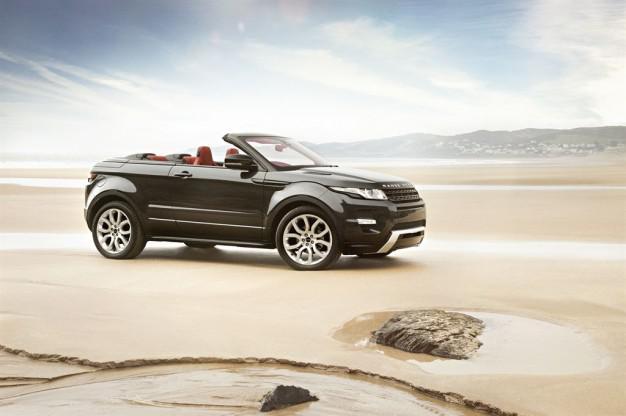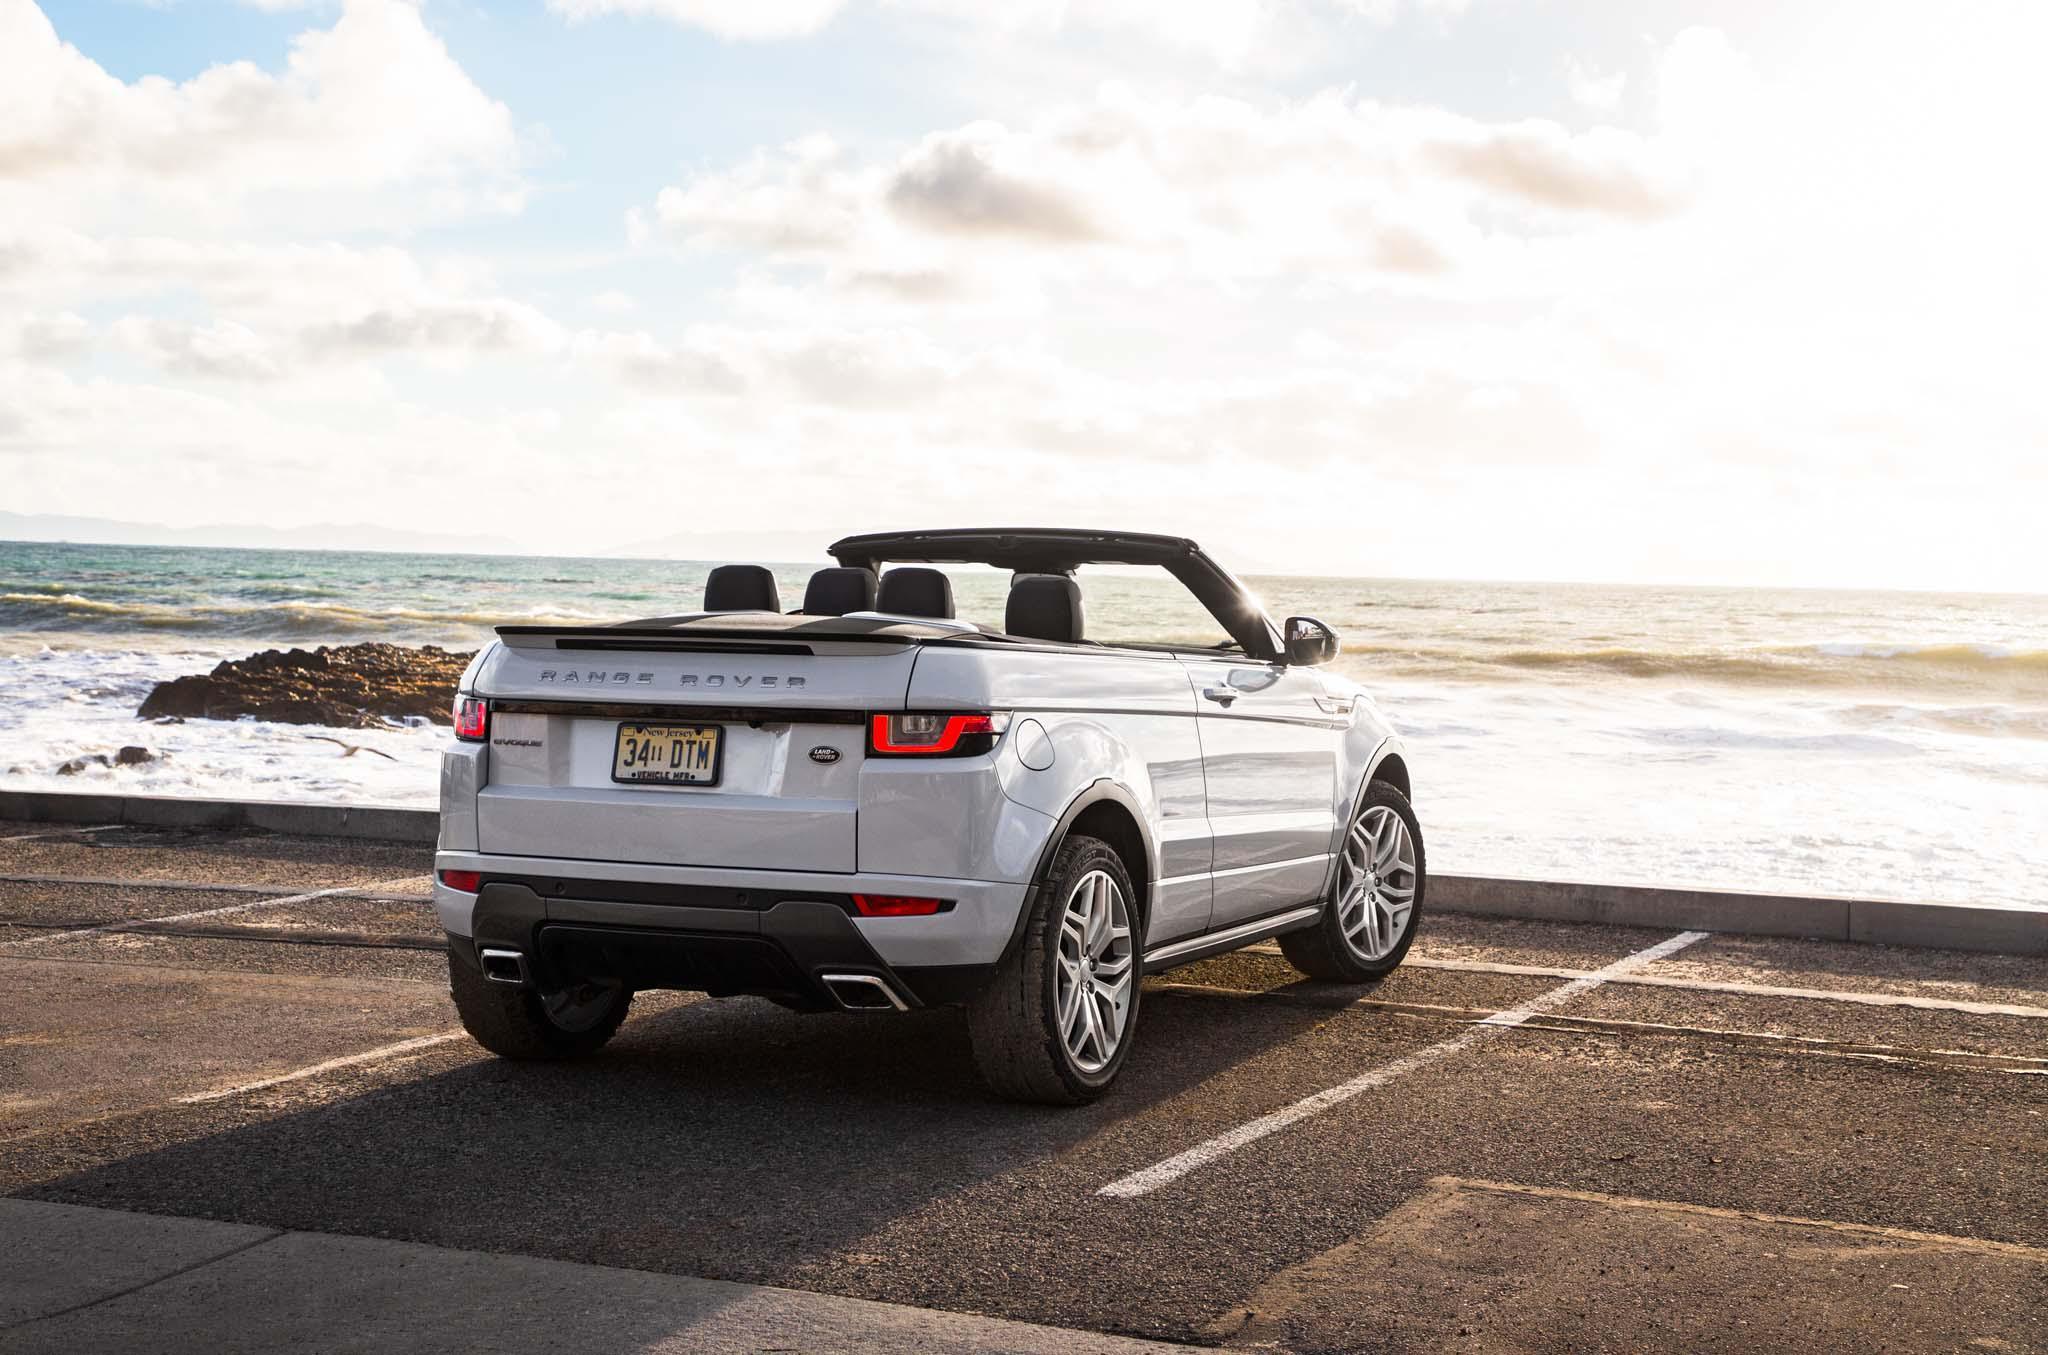The first image is the image on the left, the second image is the image on the right. For the images displayed, is the sentence "The right image features one white topless convertible parked in a marked space facing the ocean, with its rear to the camera." factually correct? Answer yes or no. Yes. The first image is the image on the left, the second image is the image on the right. Given the left and right images, does the statement "In one if the images, a car is facing the water and you can see its back licence plate." hold true? Answer yes or no. Yes. 